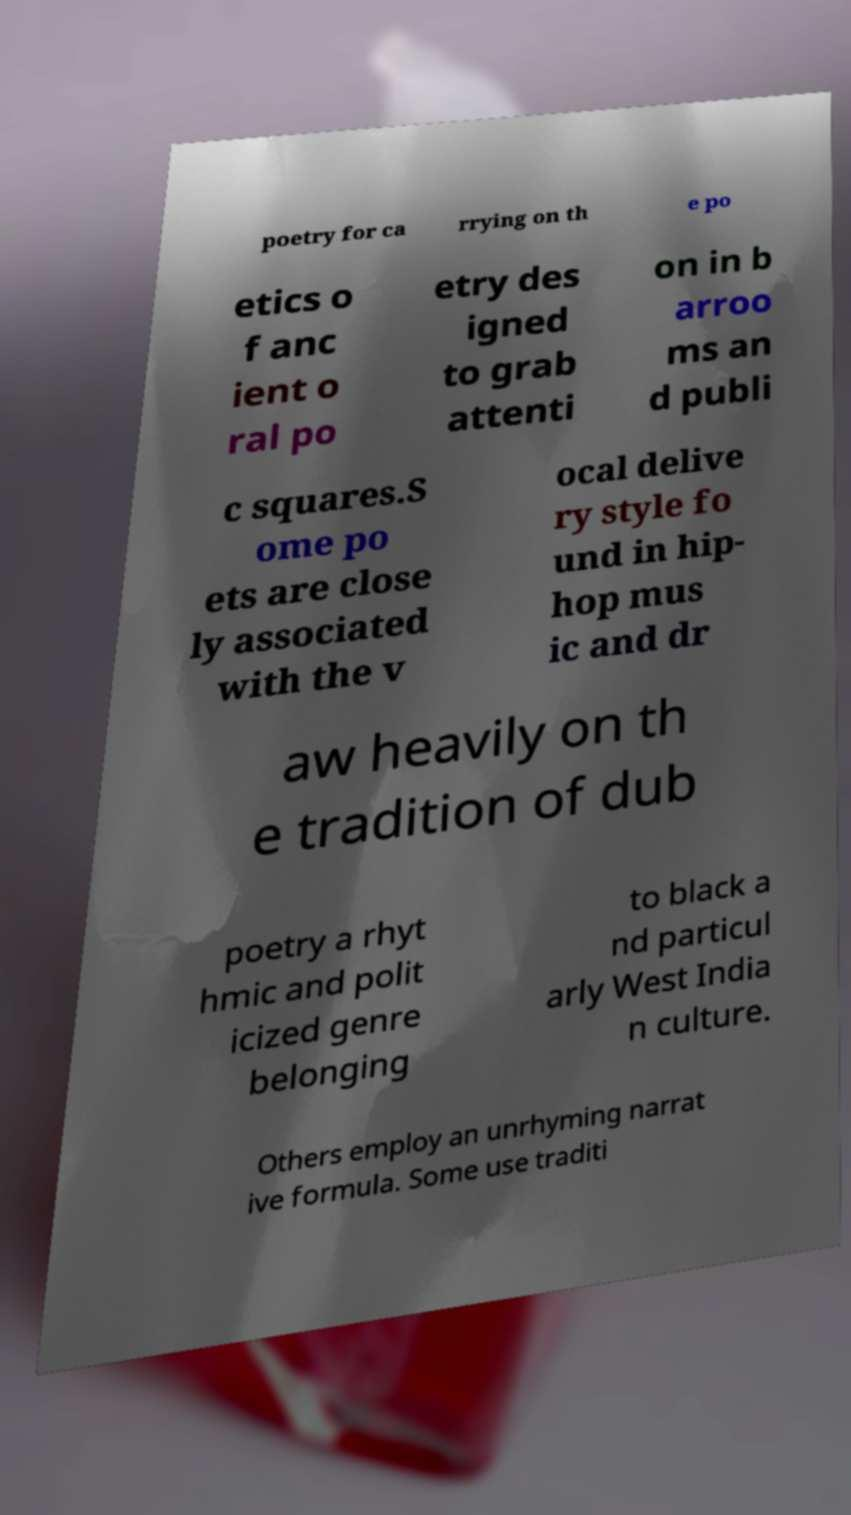Please read and relay the text visible in this image. What does it say? poetry for ca rrying on th e po etics o f anc ient o ral po etry des igned to grab attenti on in b arroo ms an d publi c squares.S ome po ets are close ly associated with the v ocal delive ry style fo und in hip- hop mus ic and dr aw heavily on th e tradition of dub poetry a rhyt hmic and polit icized genre belonging to black a nd particul arly West India n culture. Others employ an unrhyming narrat ive formula. Some use traditi 